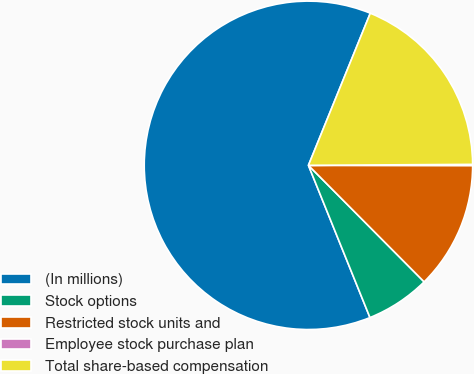Convert chart. <chart><loc_0><loc_0><loc_500><loc_500><pie_chart><fcel>(In millions)<fcel>Stock options<fcel>Restricted stock units and<fcel>Employee stock purchase plan<fcel>Total share-based compensation<nl><fcel>62.26%<fcel>6.33%<fcel>12.54%<fcel>0.11%<fcel>18.76%<nl></chart> 